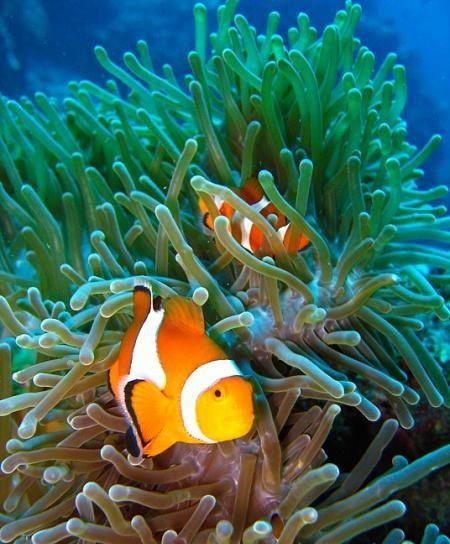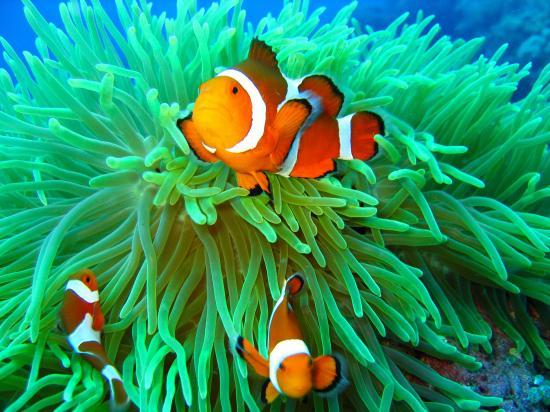The first image is the image on the left, the second image is the image on the right. Given the left and right images, does the statement "Each image shows orange-and-white clown fish swimming among slender green anemone tendrils." hold true? Answer yes or no. Yes. The first image is the image on the left, the second image is the image on the right. Assess this claim about the two images: "There is exactly one fish in the right image.". Correct or not? Answer yes or no. No. 